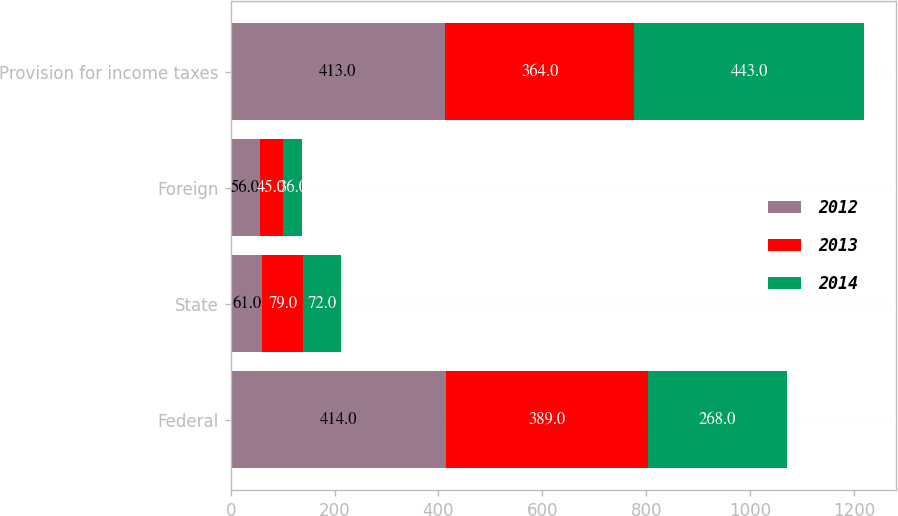Convert chart. <chart><loc_0><loc_0><loc_500><loc_500><stacked_bar_chart><ecel><fcel>Federal<fcel>State<fcel>Foreign<fcel>Provision for income taxes<nl><fcel>2012<fcel>414<fcel>61<fcel>56<fcel>413<nl><fcel>2013<fcel>389<fcel>79<fcel>45<fcel>364<nl><fcel>2014<fcel>268<fcel>72<fcel>36<fcel>443<nl></chart> 